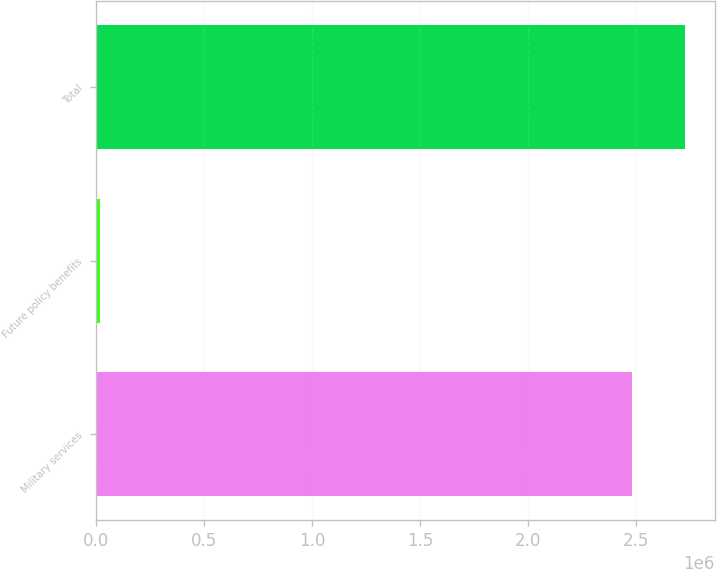Convert chart to OTSL. <chart><loc_0><loc_0><loc_500><loc_500><bar_chart><fcel>Military services<fcel>Future policy benefits<fcel>Total<nl><fcel>2.48181e+06<fcel>16392<fcel>2.73e+06<nl></chart> 